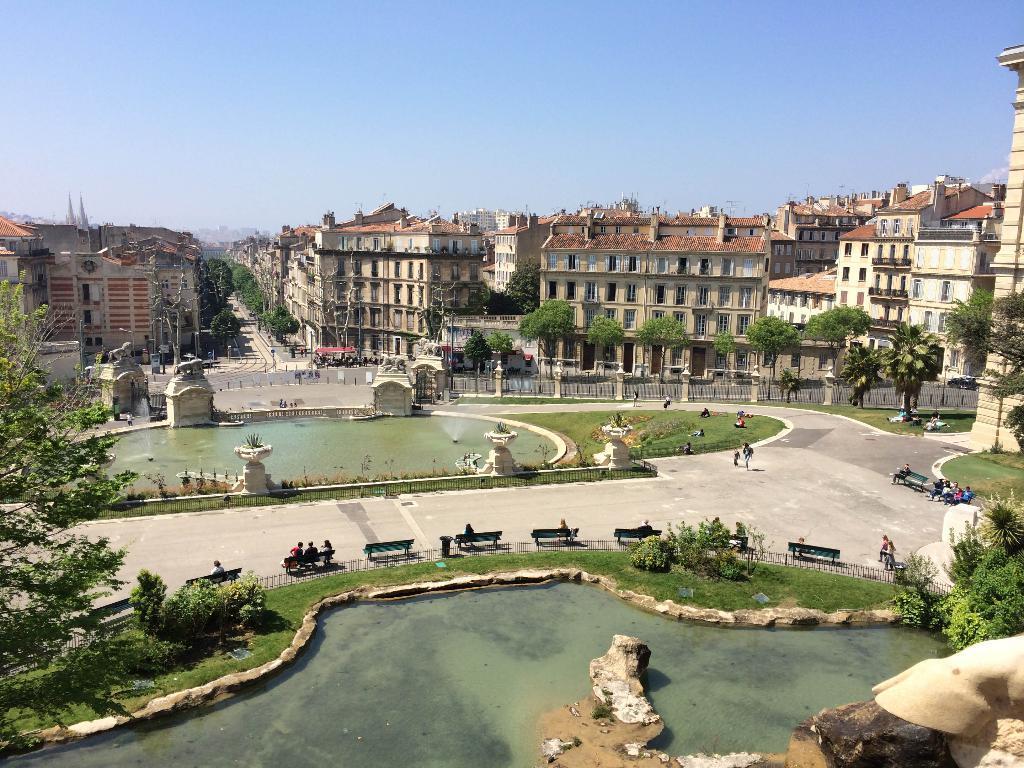In one or two sentences, can you explain what this image depicts? In this picture we can see water at the bottom, in the background there are some buildings, we can see grass, some plants, benches, trees, some boards and some people in the middle, there are some people sitting on these benches, there is the sky at the top of the picture. 